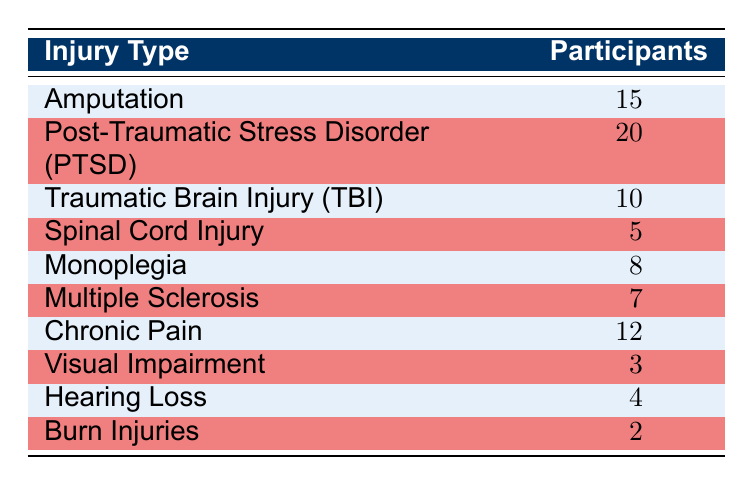What is the total number of participants represented in the table? To find the total number of participants, we need to sum the number of participants for each type of injury. The values are: 15 (Amputation) + 20 (PTSD) + 10 (TBI) + 5 (Spinal Cord Injury) + 8 (Monoplegia) + 7 (Multiple Sclerosis) + 12 (Chronic Pain) + 3 (Visual Impairment) + 4 (Hearing Loss) + 2 (Burn Injuries) = 82.
Answer: 82 Which injury type has the highest number of participants? By looking at the table, we compare the number of participants for each injury type. Post-Traumatic Stress Disorder (PTSD) has 20 participants, which is more than any other category listed.
Answer: Post-Traumatic Stress Disorder (PTSD) Is the number of participants with Visual Impairment greater than those with Burn Injuries? The table shows 3 participants with Visual Impairment and 2 participants with Burn Injuries. Comparing these two values, 3 is greater than 2, making this statement true.
Answer: Yes What is the average number of participants across all injury types? To calculate the average, we first sum the total number of participants (82, as calculated before) and divide it by the total number of injury types, which is 10. Thus, the average is 82/10 = 8.2.
Answer: 8.2 How many more participants have Chronic Pain compared to Spinal Cord Injury? We look at the number of participants for each injury type: Chronic Pain has 12 and Spinal Cord Injury has 5. The difference is calculated as 12 - 5 = 7.
Answer: 7 Which injury types have less than 5 participants? We check each injury type's number of participants. The table shows that Burn Injuries has 2 and Visual Impairment has 3. Both injury types have less than 5 participants.
Answer: Burn Injuries and Visual Impairment What percentage of participants have Monoplegia compared to the total participants? To find the percentage, we take the number of participants with Monoplegia (8) and divide it by the total number of participants (82). Then, multiply by 100 to convert to a percentage: (8/82) * 100 ≈ 9.76.
Answer: Approximately 9.76% Are there more types of injury with 10 or more participants than those with fewer than 10? Reviewing the table, we note that the injuries with 10 or more participants are PTSD (20), Amputation (15), TBI (10), and Chronic Pain (12), totaling 4 types. The injuries with fewer than 10 participants are Monoplegia (8), Multiple Sclerosis (7), Visual Impairment (3), Hearing Loss (4), and Burn Injuries (2), totaling 5 types. This shows there are more injury types with fewer than 10 participants.
Answer: No 